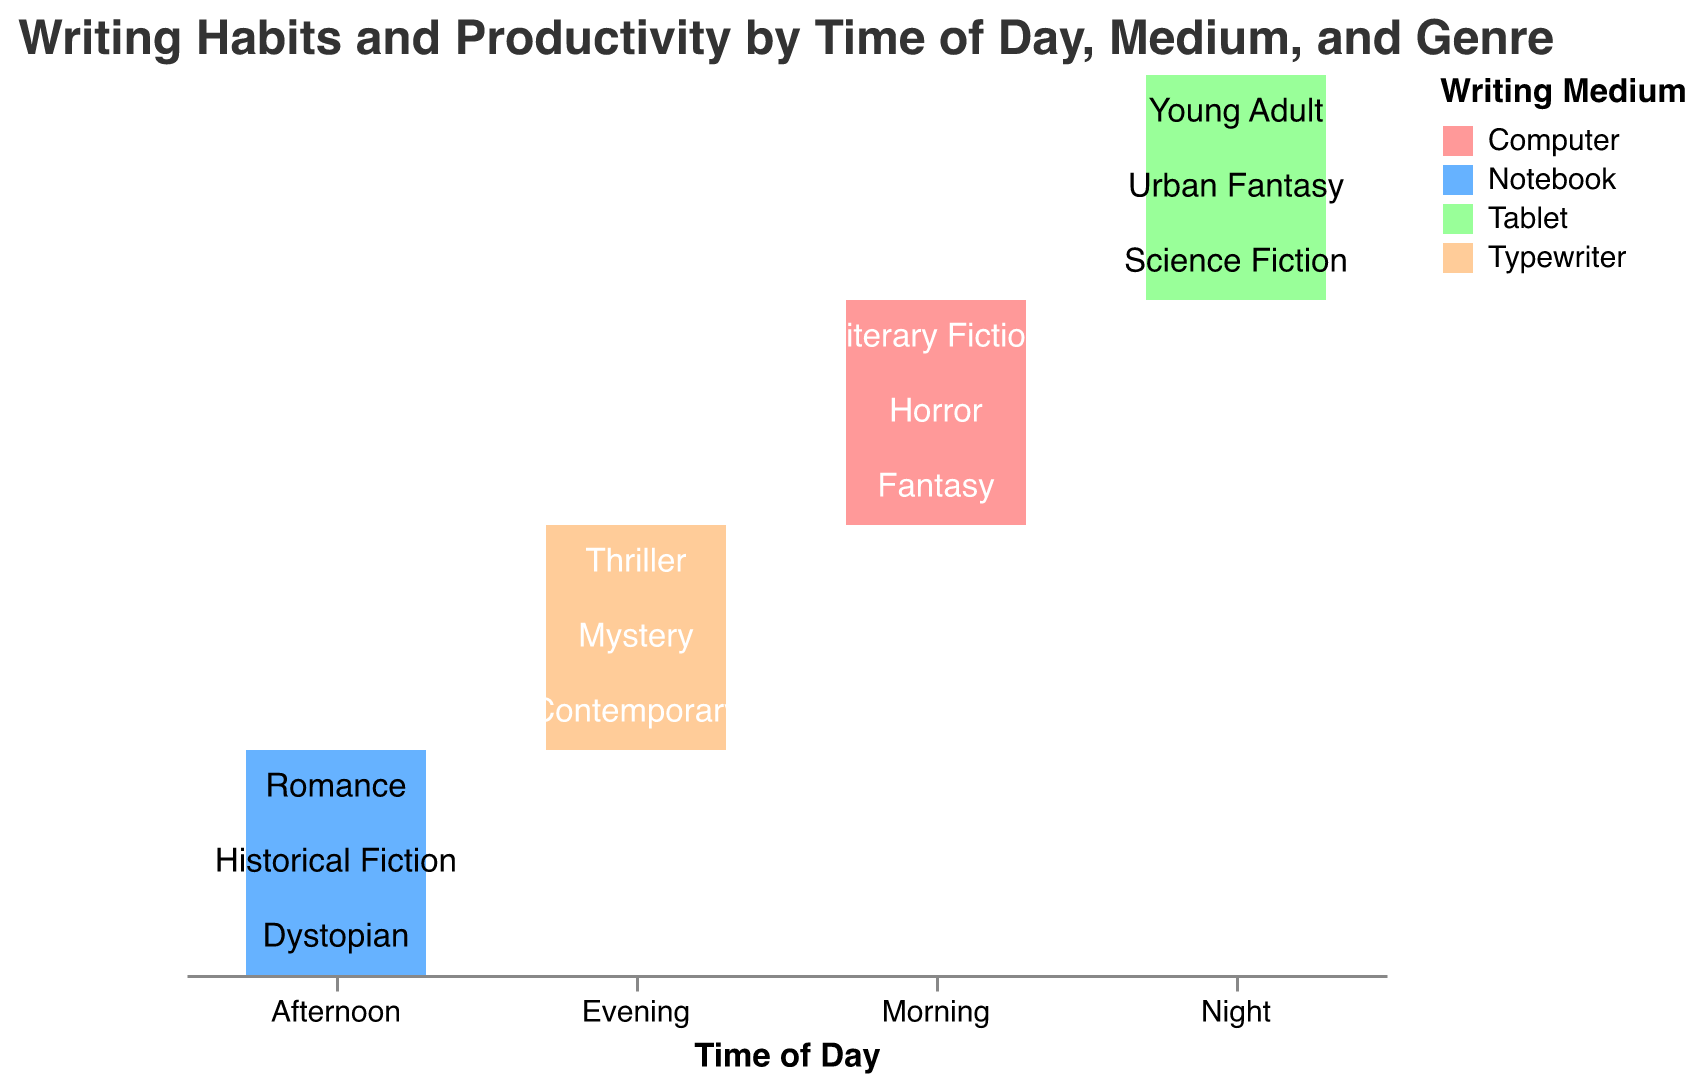What is the title of the figure? The title is usually prominently displayed at the top of the figure. It helps to understand what the plot is about before delving into the details.
Answer: Writing Habits and Productivity by Time of Day, Medium, and Genre Which writing medium is most frequently used in the morning? To find this, look for the section of the mosaic plot labeled "Morning" on the x-axis. The color representing the writing medium with the largest segment in that section indicates the most frequently used medium.
Answer: Computer Which time of day shows the highest overall productivity? We need to compare the provided productivity values for each time of day. Night has the highest single value (4.1 for Science Fiction) and high productivity values across genres.
Answer: Night How does productivity in the evening compare to productivity in the morning? Locate the segments under "Evening" and "Morning" on the x-axis and compare the productivity values listed in the tooltip or within the plot segments for these times of day.
Answer: Evening generally shows higher productivity values than morning Which genre is associated with the highest productivity at night? Look at the "Night" section of the plot and find the genre with the highest productivity value listed.
Answer: Science Fiction How does the productivity of "Romance" written in the afternoon compare to "Historical Fiction" written at the same time? Check the productivity values for both Romance and Historical Fiction in the "Afternoon" section. Compare the values directly.
Answer: Romance (2.8) is more productive than Historical Fiction (2.5) Is there a writing medium that is not used at a particular time of day? Scan through the different sections (Morning, Afternoon, Evening, Night) and see if any writing medium is missing in these sections.
Answer: Typewriter is not used at Night Which genre has the lowest productivity in the afternoon? Look at the productivity values for different genres in the "Afternoon" section and identify the lowest value.
Answer: Historical Fiction (2.5) What time of day is most productive for writing on a Tablet? Look for the segments colored to indicate Tablet usage. Compare the productivity values in those segments for different times of day.
Answer: Night Is there a writing medium and genre combination that consistently shows above-average productivity across all times of the day? Examine each section of the plot to find a writing medium and genre combination with consistently high productivity values.
Answer: Tablet and Science Fiction show high productivity at night, while Typewriter and Thriller show high productivity in the evening, but no single combination is high across all times 